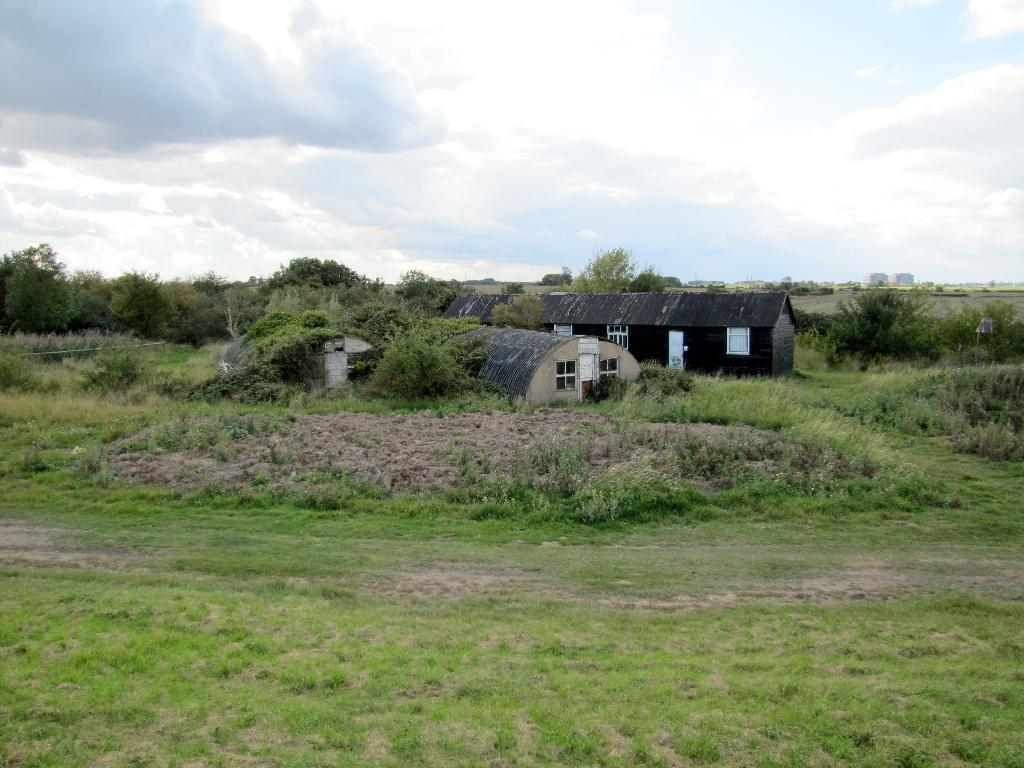What type of surface is on the ground in the image? There is grass on the ground in the image. What structures can be seen in the background of the image? There are houses and a tree in the background of the image. How would you describe the sky in the image? The sky is blue and cloudy in the image. Where is the desk located in the image? There is no desk present in the image. What type of shop can be seen in the background of the image? There is no shop visible in the image; only houses and a tree are present in the background. 